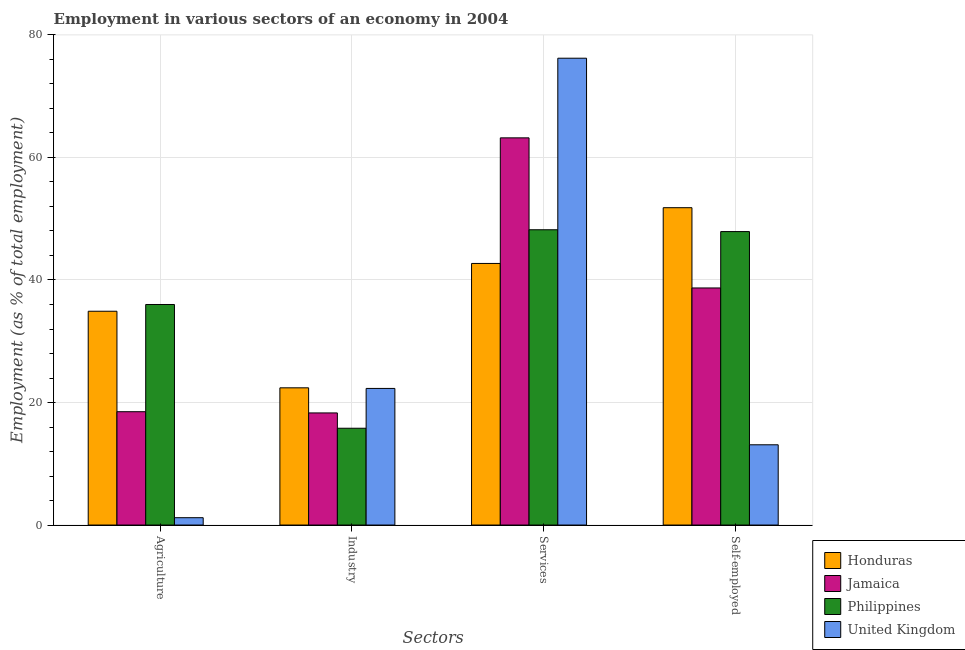How many different coloured bars are there?
Your answer should be compact. 4. How many groups of bars are there?
Make the answer very short. 4. Are the number of bars per tick equal to the number of legend labels?
Keep it short and to the point. Yes. Are the number of bars on each tick of the X-axis equal?
Offer a terse response. Yes. How many bars are there on the 2nd tick from the right?
Offer a very short reply. 4. What is the label of the 3rd group of bars from the left?
Provide a short and direct response. Services. What is the percentage of workers in agriculture in United Kingdom?
Give a very brief answer. 1.2. Across all countries, what is the maximum percentage of workers in services?
Offer a very short reply. 76.2. Across all countries, what is the minimum percentage of workers in industry?
Give a very brief answer. 15.8. In which country was the percentage of self employed workers maximum?
Make the answer very short. Honduras. In which country was the percentage of workers in services minimum?
Your answer should be compact. Honduras. What is the total percentage of workers in industry in the graph?
Give a very brief answer. 78.8. What is the difference between the percentage of workers in services in Honduras and that in United Kingdom?
Give a very brief answer. -33.5. What is the difference between the percentage of workers in industry in Philippines and the percentage of workers in agriculture in Honduras?
Provide a short and direct response. -19.1. What is the average percentage of self employed workers per country?
Offer a terse response. 37.88. What is the difference between the percentage of workers in agriculture and percentage of workers in industry in Honduras?
Your answer should be compact. 12.5. In how many countries, is the percentage of workers in industry greater than 8 %?
Make the answer very short. 4. What is the ratio of the percentage of workers in industry in Honduras to that in Philippines?
Give a very brief answer. 1.42. Is the percentage of self employed workers in Honduras less than that in United Kingdom?
Your answer should be very brief. No. Is the difference between the percentage of workers in industry in Philippines and Jamaica greater than the difference between the percentage of workers in services in Philippines and Jamaica?
Provide a succinct answer. Yes. What is the difference between the highest and the second highest percentage of workers in services?
Provide a short and direct response. 13. What is the difference between the highest and the lowest percentage of workers in industry?
Offer a very short reply. 6.6. In how many countries, is the percentage of workers in services greater than the average percentage of workers in services taken over all countries?
Your response must be concise. 2. Is it the case that in every country, the sum of the percentage of workers in agriculture and percentage of workers in services is greater than the sum of percentage of workers in industry and percentage of self employed workers?
Offer a very short reply. No. What does the 1st bar from the left in Industry represents?
Your response must be concise. Honduras. What does the 1st bar from the right in Agriculture represents?
Offer a very short reply. United Kingdom. Is it the case that in every country, the sum of the percentage of workers in agriculture and percentage of workers in industry is greater than the percentage of workers in services?
Offer a very short reply. No. What is the title of the graph?
Your answer should be very brief. Employment in various sectors of an economy in 2004. What is the label or title of the X-axis?
Your response must be concise. Sectors. What is the label or title of the Y-axis?
Give a very brief answer. Employment (as % of total employment). What is the Employment (as % of total employment) of Honduras in Agriculture?
Provide a succinct answer. 34.9. What is the Employment (as % of total employment) in Jamaica in Agriculture?
Keep it short and to the point. 18.5. What is the Employment (as % of total employment) of Philippines in Agriculture?
Your response must be concise. 36. What is the Employment (as % of total employment) of United Kingdom in Agriculture?
Give a very brief answer. 1.2. What is the Employment (as % of total employment) of Honduras in Industry?
Give a very brief answer. 22.4. What is the Employment (as % of total employment) of Jamaica in Industry?
Provide a succinct answer. 18.3. What is the Employment (as % of total employment) of Philippines in Industry?
Your response must be concise. 15.8. What is the Employment (as % of total employment) of United Kingdom in Industry?
Keep it short and to the point. 22.3. What is the Employment (as % of total employment) in Honduras in Services?
Make the answer very short. 42.7. What is the Employment (as % of total employment) in Jamaica in Services?
Ensure brevity in your answer.  63.2. What is the Employment (as % of total employment) of Philippines in Services?
Offer a very short reply. 48.2. What is the Employment (as % of total employment) in United Kingdom in Services?
Give a very brief answer. 76.2. What is the Employment (as % of total employment) in Honduras in Self-employed?
Ensure brevity in your answer.  51.8. What is the Employment (as % of total employment) of Jamaica in Self-employed?
Provide a short and direct response. 38.7. What is the Employment (as % of total employment) in Philippines in Self-employed?
Offer a terse response. 47.9. What is the Employment (as % of total employment) of United Kingdom in Self-employed?
Your answer should be very brief. 13.1. Across all Sectors, what is the maximum Employment (as % of total employment) in Honduras?
Your answer should be very brief. 51.8. Across all Sectors, what is the maximum Employment (as % of total employment) in Jamaica?
Your answer should be very brief. 63.2. Across all Sectors, what is the maximum Employment (as % of total employment) of Philippines?
Offer a very short reply. 48.2. Across all Sectors, what is the maximum Employment (as % of total employment) of United Kingdom?
Your answer should be very brief. 76.2. Across all Sectors, what is the minimum Employment (as % of total employment) in Honduras?
Provide a succinct answer. 22.4. Across all Sectors, what is the minimum Employment (as % of total employment) in Jamaica?
Keep it short and to the point. 18.3. Across all Sectors, what is the minimum Employment (as % of total employment) in Philippines?
Your response must be concise. 15.8. Across all Sectors, what is the minimum Employment (as % of total employment) in United Kingdom?
Provide a short and direct response. 1.2. What is the total Employment (as % of total employment) of Honduras in the graph?
Ensure brevity in your answer.  151.8. What is the total Employment (as % of total employment) in Jamaica in the graph?
Provide a short and direct response. 138.7. What is the total Employment (as % of total employment) in Philippines in the graph?
Provide a succinct answer. 147.9. What is the total Employment (as % of total employment) of United Kingdom in the graph?
Give a very brief answer. 112.8. What is the difference between the Employment (as % of total employment) of Philippines in Agriculture and that in Industry?
Keep it short and to the point. 20.2. What is the difference between the Employment (as % of total employment) of United Kingdom in Agriculture and that in Industry?
Your response must be concise. -21.1. What is the difference between the Employment (as % of total employment) in Jamaica in Agriculture and that in Services?
Offer a very short reply. -44.7. What is the difference between the Employment (as % of total employment) of United Kingdom in Agriculture and that in Services?
Offer a very short reply. -75. What is the difference between the Employment (as % of total employment) in Honduras in Agriculture and that in Self-employed?
Make the answer very short. -16.9. What is the difference between the Employment (as % of total employment) of Jamaica in Agriculture and that in Self-employed?
Your answer should be very brief. -20.2. What is the difference between the Employment (as % of total employment) of United Kingdom in Agriculture and that in Self-employed?
Provide a succinct answer. -11.9. What is the difference between the Employment (as % of total employment) in Honduras in Industry and that in Services?
Provide a short and direct response. -20.3. What is the difference between the Employment (as % of total employment) in Jamaica in Industry and that in Services?
Make the answer very short. -44.9. What is the difference between the Employment (as % of total employment) of Philippines in Industry and that in Services?
Ensure brevity in your answer.  -32.4. What is the difference between the Employment (as % of total employment) in United Kingdom in Industry and that in Services?
Keep it short and to the point. -53.9. What is the difference between the Employment (as % of total employment) in Honduras in Industry and that in Self-employed?
Keep it short and to the point. -29.4. What is the difference between the Employment (as % of total employment) in Jamaica in Industry and that in Self-employed?
Your answer should be very brief. -20.4. What is the difference between the Employment (as % of total employment) of Philippines in Industry and that in Self-employed?
Your response must be concise. -32.1. What is the difference between the Employment (as % of total employment) in Jamaica in Services and that in Self-employed?
Make the answer very short. 24.5. What is the difference between the Employment (as % of total employment) of United Kingdom in Services and that in Self-employed?
Ensure brevity in your answer.  63.1. What is the difference between the Employment (as % of total employment) of Honduras in Agriculture and the Employment (as % of total employment) of Jamaica in Industry?
Your answer should be compact. 16.6. What is the difference between the Employment (as % of total employment) of Jamaica in Agriculture and the Employment (as % of total employment) of Philippines in Industry?
Your answer should be very brief. 2.7. What is the difference between the Employment (as % of total employment) of Jamaica in Agriculture and the Employment (as % of total employment) of United Kingdom in Industry?
Offer a terse response. -3.8. What is the difference between the Employment (as % of total employment) of Honduras in Agriculture and the Employment (as % of total employment) of Jamaica in Services?
Provide a succinct answer. -28.3. What is the difference between the Employment (as % of total employment) of Honduras in Agriculture and the Employment (as % of total employment) of United Kingdom in Services?
Your answer should be very brief. -41.3. What is the difference between the Employment (as % of total employment) of Jamaica in Agriculture and the Employment (as % of total employment) of Philippines in Services?
Your answer should be very brief. -29.7. What is the difference between the Employment (as % of total employment) in Jamaica in Agriculture and the Employment (as % of total employment) in United Kingdom in Services?
Make the answer very short. -57.7. What is the difference between the Employment (as % of total employment) of Philippines in Agriculture and the Employment (as % of total employment) of United Kingdom in Services?
Give a very brief answer. -40.2. What is the difference between the Employment (as % of total employment) of Honduras in Agriculture and the Employment (as % of total employment) of Jamaica in Self-employed?
Make the answer very short. -3.8. What is the difference between the Employment (as % of total employment) of Honduras in Agriculture and the Employment (as % of total employment) of Philippines in Self-employed?
Your answer should be very brief. -13. What is the difference between the Employment (as % of total employment) of Honduras in Agriculture and the Employment (as % of total employment) of United Kingdom in Self-employed?
Offer a very short reply. 21.8. What is the difference between the Employment (as % of total employment) in Jamaica in Agriculture and the Employment (as % of total employment) in Philippines in Self-employed?
Offer a terse response. -29.4. What is the difference between the Employment (as % of total employment) of Philippines in Agriculture and the Employment (as % of total employment) of United Kingdom in Self-employed?
Provide a succinct answer. 22.9. What is the difference between the Employment (as % of total employment) in Honduras in Industry and the Employment (as % of total employment) in Jamaica in Services?
Your answer should be very brief. -40.8. What is the difference between the Employment (as % of total employment) of Honduras in Industry and the Employment (as % of total employment) of Philippines in Services?
Keep it short and to the point. -25.8. What is the difference between the Employment (as % of total employment) of Honduras in Industry and the Employment (as % of total employment) of United Kingdom in Services?
Make the answer very short. -53.8. What is the difference between the Employment (as % of total employment) in Jamaica in Industry and the Employment (as % of total employment) in Philippines in Services?
Your answer should be compact. -29.9. What is the difference between the Employment (as % of total employment) in Jamaica in Industry and the Employment (as % of total employment) in United Kingdom in Services?
Make the answer very short. -57.9. What is the difference between the Employment (as % of total employment) in Philippines in Industry and the Employment (as % of total employment) in United Kingdom in Services?
Your response must be concise. -60.4. What is the difference between the Employment (as % of total employment) of Honduras in Industry and the Employment (as % of total employment) of Jamaica in Self-employed?
Provide a succinct answer. -16.3. What is the difference between the Employment (as % of total employment) in Honduras in Industry and the Employment (as % of total employment) in Philippines in Self-employed?
Keep it short and to the point. -25.5. What is the difference between the Employment (as % of total employment) in Jamaica in Industry and the Employment (as % of total employment) in Philippines in Self-employed?
Offer a terse response. -29.6. What is the difference between the Employment (as % of total employment) in Philippines in Industry and the Employment (as % of total employment) in United Kingdom in Self-employed?
Your answer should be very brief. 2.7. What is the difference between the Employment (as % of total employment) in Honduras in Services and the Employment (as % of total employment) in Jamaica in Self-employed?
Give a very brief answer. 4. What is the difference between the Employment (as % of total employment) in Honduras in Services and the Employment (as % of total employment) in United Kingdom in Self-employed?
Make the answer very short. 29.6. What is the difference between the Employment (as % of total employment) of Jamaica in Services and the Employment (as % of total employment) of United Kingdom in Self-employed?
Offer a very short reply. 50.1. What is the difference between the Employment (as % of total employment) of Philippines in Services and the Employment (as % of total employment) of United Kingdom in Self-employed?
Offer a very short reply. 35.1. What is the average Employment (as % of total employment) of Honduras per Sectors?
Your answer should be very brief. 37.95. What is the average Employment (as % of total employment) of Jamaica per Sectors?
Provide a succinct answer. 34.67. What is the average Employment (as % of total employment) in Philippines per Sectors?
Your answer should be compact. 36.98. What is the average Employment (as % of total employment) of United Kingdom per Sectors?
Offer a terse response. 28.2. What is the difference between the Employment (as % of total employment) of Honduras and Employment (as % of total employment) of Jamaica in Agriculture?
Keep it short and to the point. 16.4. What is the difference between the Employment (as % of total employment) of Honduras and Employment (as % of total employment) of Philippines in Agriculture?
Give a very brief answer. -1.1. What is the difference between the Employment (as % of total employment) of Honduras and Employment (as % of total employment) of United Kingdom in Agriculture?
Your answer should be very brief. 33.7. What is the difference between the Employment (as % of total employment) of Jamaica and Employment (as % of total employment) of Philippines in Agriculture?
Your answer should be compact. -17.5. What is the difference between the Employment (as % of total employment) in Philippines and Employment (as % of total employment) in United Kingdom in Agriculture?
Give a very brief answer. 34.8. What is the difference between the Employment (as % of total employment) in Jamaica and Employment (as % of total employment) in United Kingdom in Industry?
Your answer should be very brief. -4. What is the difference between the Employment (as % of total employment) of Philippines and Employment (as % of total employment) of United Kingdom in Industry?
Your answer should be very brief. -6.5. What is the difference between the Employment (as % of total employment) of Honduras and Employment (as % of total employment) of Jamaica in Services?
Give a very brief answer. -20.5. What is the difference between the Employment (as % of total employment) in Honduras and Employment (as % of total employment) in Philippines in Services?
Make the answer very short. -5.5. What is the difference between the Employment (as % of total employment) in Honduras and Employment (as % of total employment) in United Kingdom in Services?
Your answer should be compact. -33.5. What is the difference between the Employment (as % of total employment) in Jamaica and Employment (as % of total employment) in Philippines in Services?
Provide a succinct answer. 15. What is the difference between the Employment (as % of total employment) in Philippines and Employment (as % of total employment) in United Kingdom in Services?
Your answer should be very brief. -28. What is the difference between the Employment (as % of total employment) in Honduras and Employment (as % of total employment) in Philippines in Self-employed?
Give a very brief answer. 3.9. What is the difference between the Employment (as % of total employment) in Honduras and Employment (as % of total employment) in United Kingdom in Self-employed?
Provide a succinct answer. 38.7. What is the difference between the Employment (as % of total employment) in Jamaica and Employment (as % of total employment) in Philippines in Self-employed?
Keep it short and to the point. -9.2. What is the difference between the Employment (as % of total employment) in Jamaica and Employment (as % of total employment) in United Kingdom in Self-employed?
Your response must be concise. 25.6. What is the difference between the Employment (as % of total employment) in Philippines and Employment (as % of total employment) in United Kingdom in Self-employed?
Your answer should be compact. 34.8. What is the ratio of the Employment (as % of total employment) in Honduras in Agriculture to that in Industry?
Offer a very short reply. 1.56. What is the ratio of the Employment (as % of total employment) of Jamaica in Agriculture to that in Industry?
Provide a short and direct response. 1.01. What is the ratio of the Employment (as % of total employment) of Philippines in Agriculture to that in Industry?
Provide a short and direct response. 2.28. What is the ratio of the Employment (as % of total employment) of United Kingdom in Agriculture to that in Industry?
Your response must be concise. 0.05. What is the ratio of the Employment (as % of total employment) of Honduras in Agriculture to that in Services?
Keep it short and to the point. 0.82. What is the ratio of the Employment (as % of total employment) in Jamaica in Agriculture to that in Services?
Offer a terse response. 0.29. What is the ratio of the Employment (as % of total employment) of Philippines in Agriculture to that in Services?
Offer a very short reply. 0.75. What is the ratio of the Employment (as % of total employment) of United Kingdom in Agriculture to that in Services?
Offer a terse response. 0.02. What is the ratio of the Employment (as % of total employment) of Honduras in Agriculture to that in Self-employed?
Your response must be concise. 0.67. What is the ratio of the Employment (as % of total employment) in Jamaica in Agriculture to that in Self-employed?
Give a very brief answer. 0.48. What is the ratio of the Employment (as % of total employment) of Philippines in Agriculture to that in Self-employed?
Provide a succinct answer. 0.75. What is the ratio of the Employment (as % of total employment) of United Kingdom in Agriculture to that in Self-employed?
Your answer should be compact. 0.09. What is the ratio of the Employment (as % of total employment) in Honduras in Industry to that in Services?
Your answer should be compact. 0.52. What is the ratio of the Employment (as % of total employment) in Jamaica in Industry to that in Services?
Make the answer very short. 0.29. What is the ratio of the Employment (as % of total employment) of Philippines in Industry to that in Services?
Make the answer very short. 0.33. What is the ratio of the Employment (as % of total employment) in United Kingdom in Industry to that in Services?
Make the answer very short. 0.29. What is the ratio of the Employment (as % of total employment) in Honduras in Industry to that in Self-employed?
Offer a terse response. 0.43. What is the ratio of the Employment (as % of total employment) of Jamaica in Industry to that in Self-employed?
Offer a very short reply. 0.47. What is the ratio of the Employment (as % of total employment) in Philippines in Industry to that in Self-employed?
Make the answer very short. 0.33. What is the ratio of the Employment (as % of total employment) of United Kingdom in Industry to that in Self-employed?
Keep it short and to the point. 1.7. What is the ratio of the Employment (as % of total employment) in Honduras in Services to that in Self-employed?
Offer a terse response. 0.82. What is the ratio of the Employment (as % of total employment) of Jamaica in Services to that in Self-employed?
Offer a very short reply. 1.63. What is the ratio of the Employment (as % of total employment) in United Kingdom in Services to that in Self-employed?
Your answer should be compact. 5.82. What is the difference between the highest and the second highest Employment (as % of total employment) in Jamaica?
Your answer should be compact. 24.5. What is the difference between the highest and the second highest Employment (as % of total employment) of Philippines?
Offer a terse response. 0.3. What is the difference between the highest and the second highest Employment (as % of total employment) of United Kingdom?
Offer a very short reply. 53.9. What is the difference between the highest and the lowest Employment (as % of total employment) in Honduras?
Your response must be concise. 29.4. What is the difference between the highest and the lowest Employment (as % of total employment) of Jamaica?
Provide a succinct answer. 44.9. What is the difference between the highest and the lowest Employment (as % of total employment) in Philippines?
Offer a terse response. 32.4. 